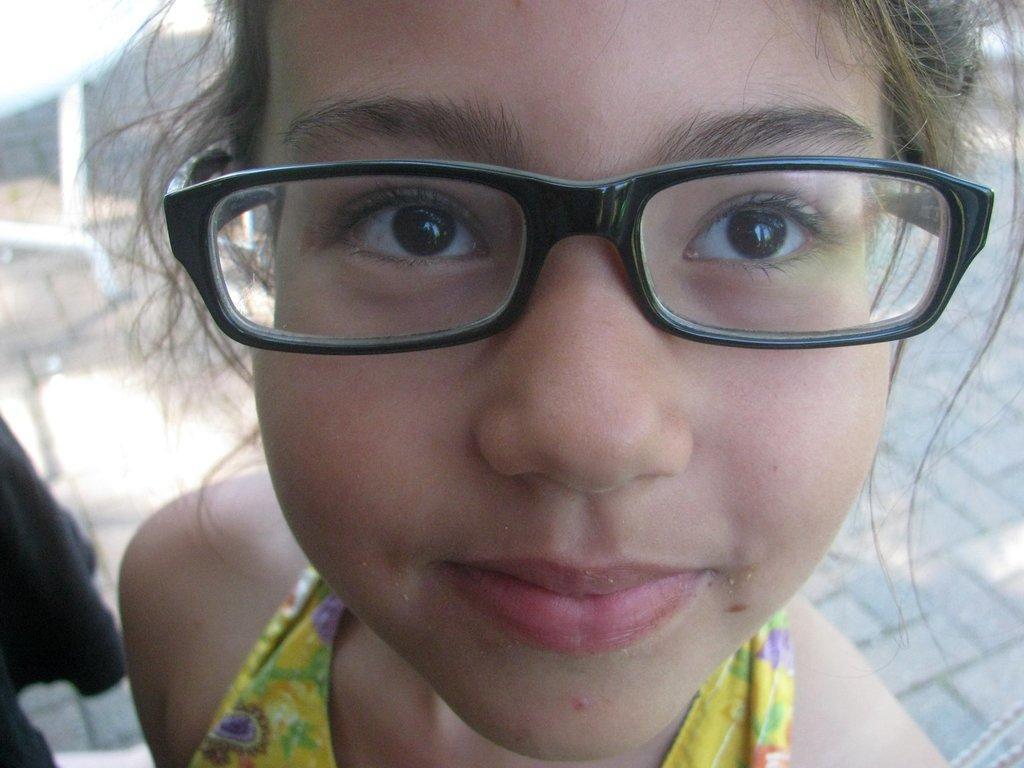Could you give a brief overview of what you see in this image? In this picture we can see a girl wearing spectacles. 